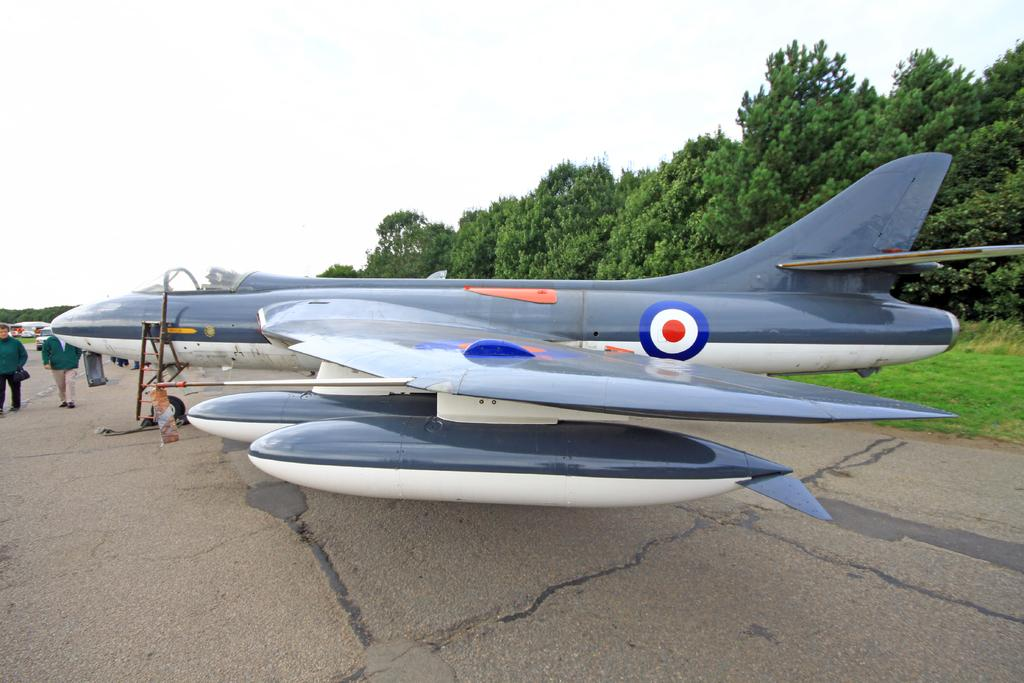What is the main subject of the image? The main subject of the image is a jet plane. What can be seen at the bottom of the image? There is a road at the bottom of the image. What is visible in the background of the image? There are trees in the background of the image. What are the two persons on the left side of the image doing? The two persons on the left side of the image are walking. What is visible at the top of the image? The sky is visible at the top of the image. Where is the art displayed in the image? There is no art displayed in the image. What type of hydrant can be seen near the jet plane in the image? There is no hydrant present in the image. 